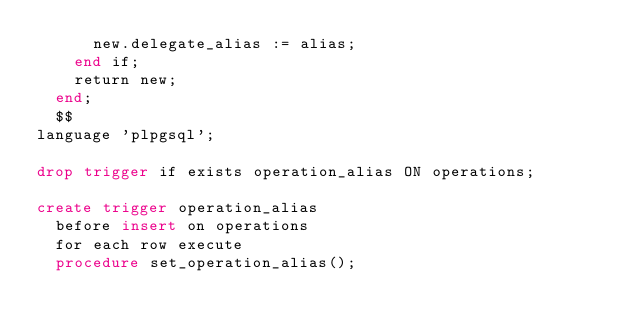Convert code to text. <code><loc_0><loc_0><loc_500><loc_500><_SQL_>			new.delegate_alias := alias;
		end if;
		return new;
	end;
	$$
language 'plpgsql';

drop trigger if exists operation_alias ON operations;

create trigger operation_alias
	before insert on operations
	for each row execute 
	procedure set_operation_alias();</code> 